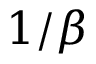<formula> <loc_0><loc_0><loc_500><loc_500>1 / \beta</formula> 